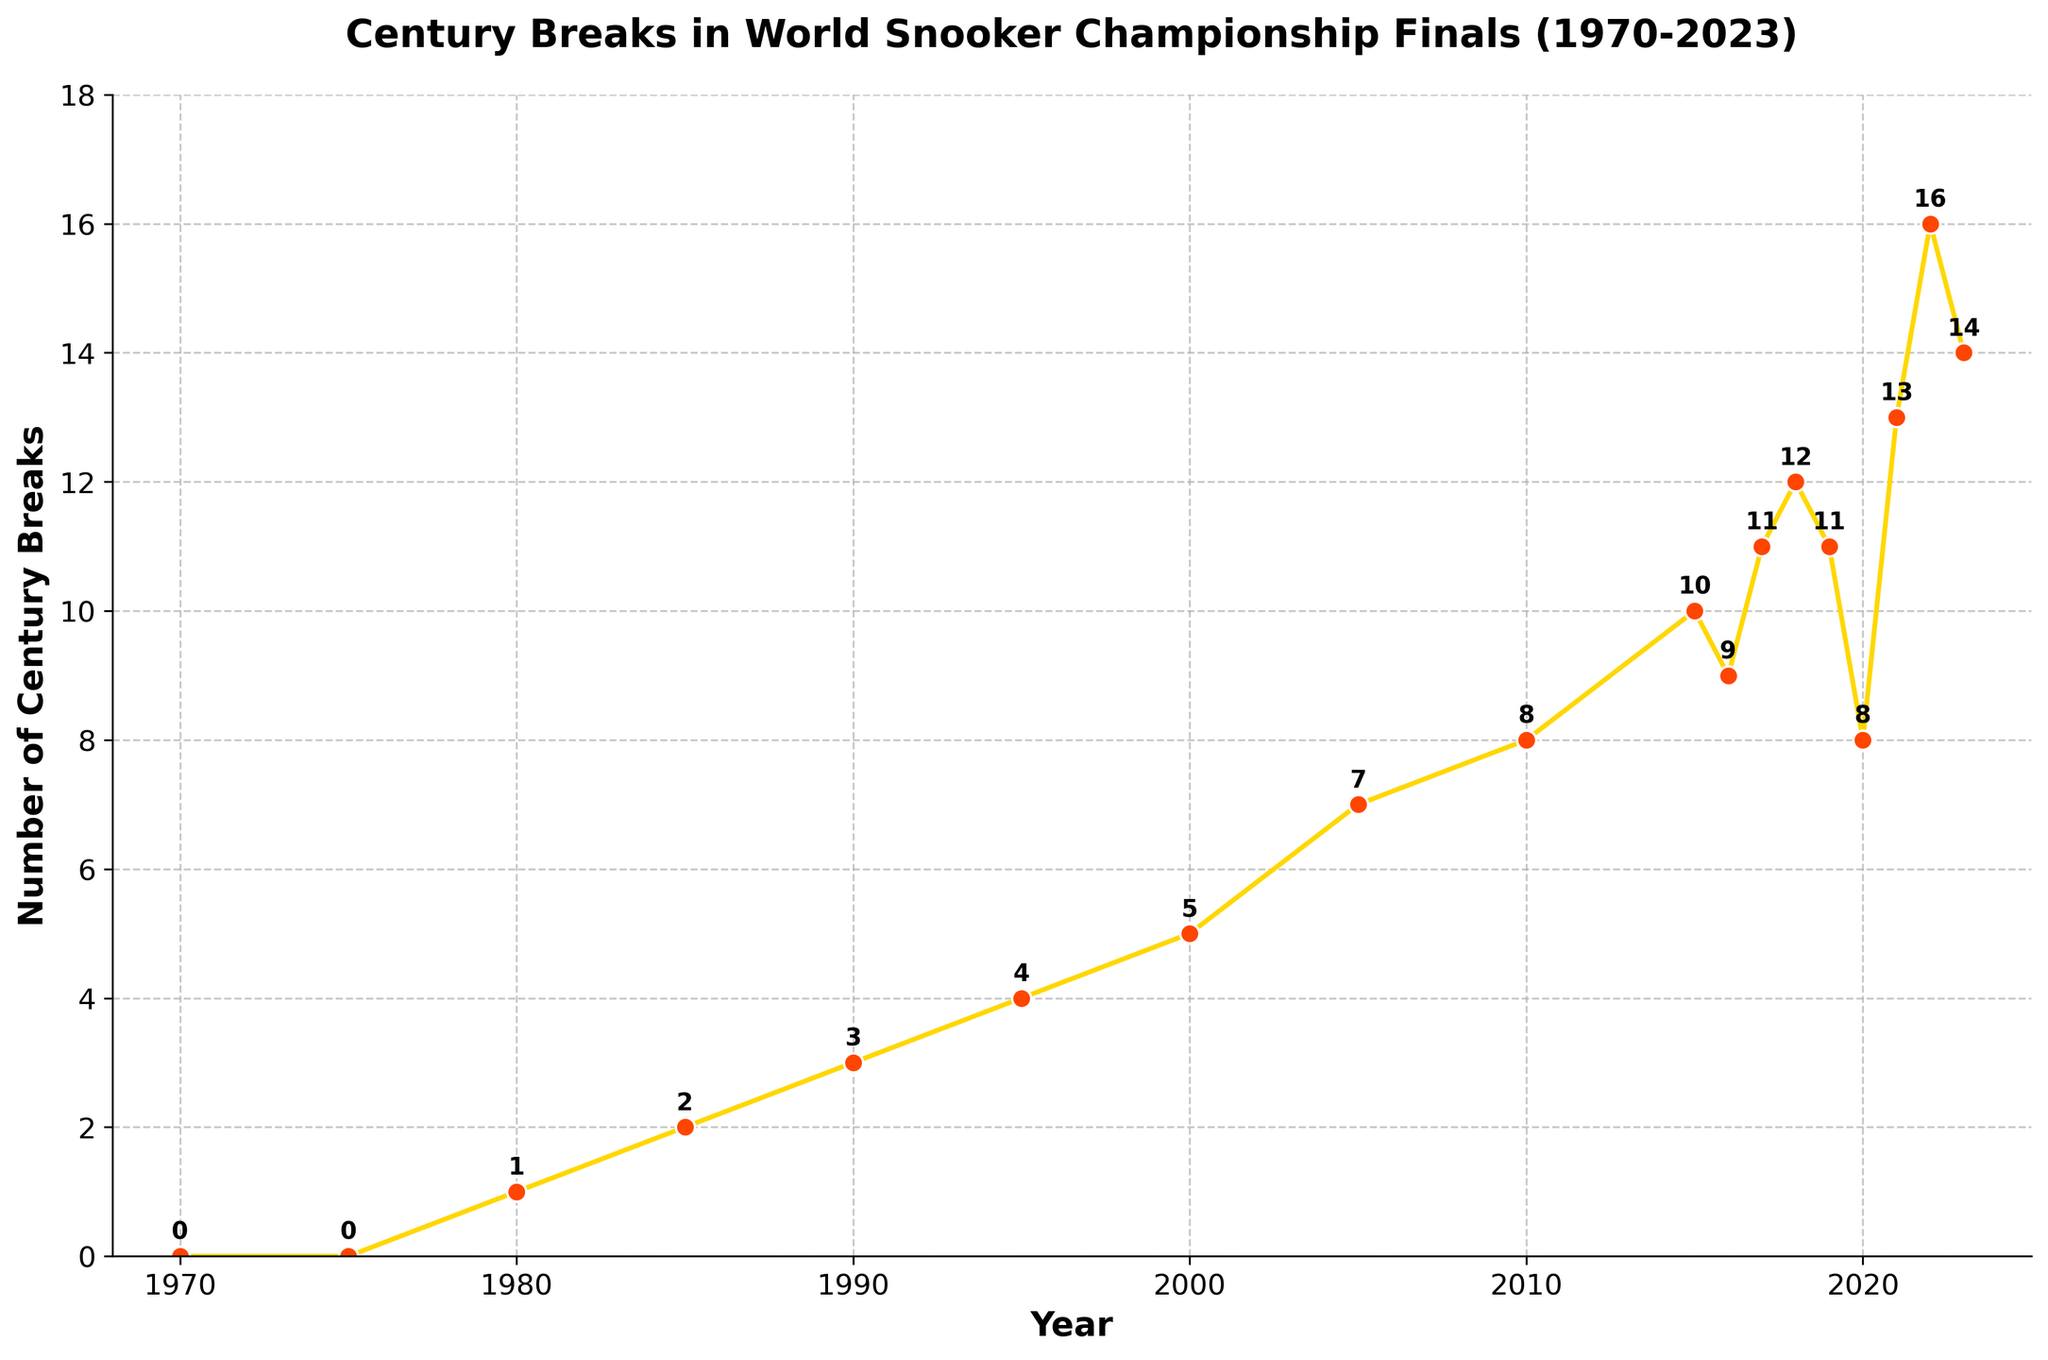When did the number of century breaks first exceed 10? The plot shows each year's century breaks with labels. The first year with more than 10 century breaks is 2017, which has 11 century breaks.
Answer: 2017 How many century breaks were there in the year 2000 compared to 1985? In 1985, there were 2 century breaks, and in 2000, there were 5 century breaks. The difference is 5 - 2 = 3.
Answer: 3 more What is the trend in the number of century breaks from 2015 to 2023? Observing the plot from 2015 (10 century breaks) to 2023 (14 century breaks), there is an overall increasing trend, although there are slight drops in some years.
Answer: Increasing Which year had the highest number of century breaks, and how many were there? By looking at the figure, the highest number of century breaks is visible in 2022, with a count of 16.
Answer: 2022, 16 How does the number of century breaks in 1990 compare to 1970? In 1970, there were 0 century breaks, and in 1990, there were 3 century breaks. The increase is 3 - 0 = 3.
Answer: 3 more What is the longest period of consecutive increase in century breaks? By examining the figure, the longest consecutive increase is from 2010 (8) to 2018 (12), which lasted for 8 years.
Answer: 8 years What are the average century breaks in the years 2010, 2015, and 2020? Adding the breaks: 8 (2010) + 10 (2015) + 8 (2020) = 26; the average is 26 / 3 = 8.67.
Answer: 8.67 Identify the years where the number of century breaks decreased compared to the previous year. From the plot, such years are 2016 (9 breaks) after 2015 (10 breaks), 2019 (11 breaks) after 2018 (12 breaks), and 2020 (8 breaks) after 2019 (11 breaks).
Answer: 2016, 2019, 2020 Compare the number of century breaks in the 1970s versus the 1990s. Summing the century breaks for each: 1970s (0 + 0 = 0), 1990s (3 + 4 = 7). The 1990s had 7 more century breaks.
Answer: 7 more What is the difference between the number of century breaks in the year with the most breaks and the year with the least breaks? The most century breaks are in 2022 (16) and the least in 1970 (0), so the difference is 16 - 0 = 16.
Answer: 16 